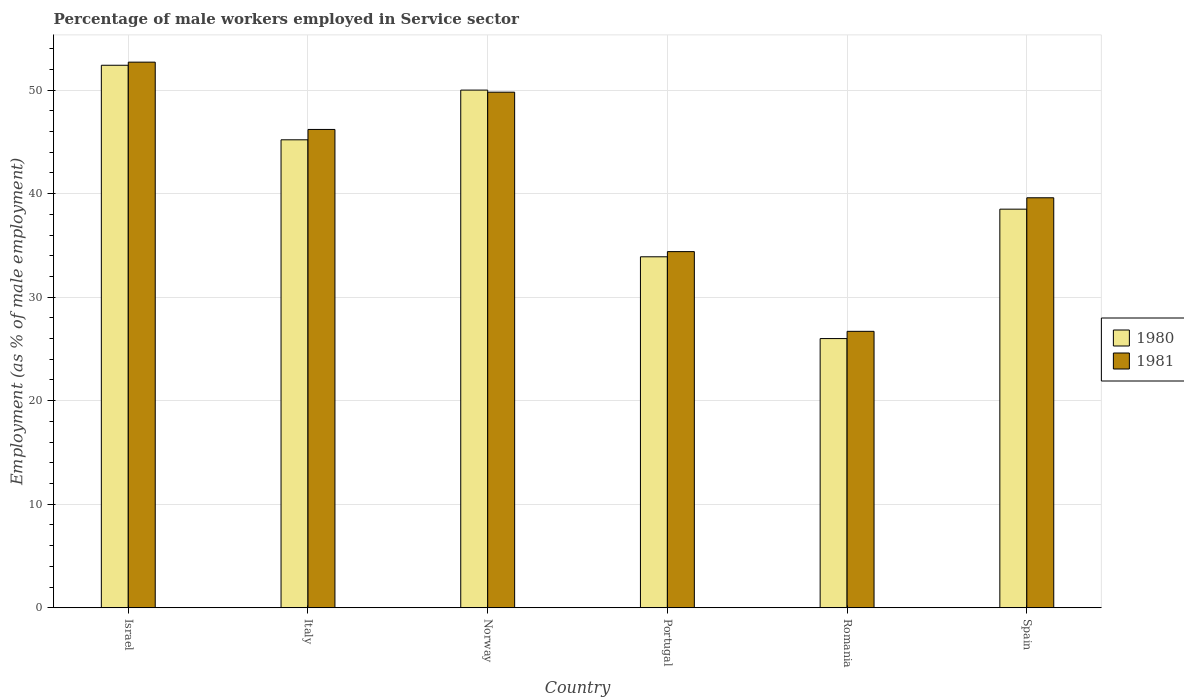How many groups of bars are there?
Provide a succinct answer. 6. Are the number of bars per tick equal to the number of legend labels?
Make the answer very short. Yes. How many bars are there on the 3rd tick from the right?
Provide a succinct answer. 2. In how many cases, is the number of bars for a given country not equal to the number of legend labels?
Your response must be concise. 0. What is the percentage of male workers employed in Service sector in 1981 in Norway?
Give a very brief answer. 49.8. Across all countries, what is the maximum percentage of male workers employed in Service sector in 1980?
Offer a very short reply. 52.4. Across all countries, what is the minimum percentage of male workers employed in Service sector in 1980?
Provide a succinct answer. 26. In which country was the percentage of male workers employed in Service sector in 1981 maximum?
Provide a succinct answer. Israel. In which country was the percentage of male workers employed in Service sector in 1980 minimum?
Ensure brevity in your answer.  Romania. What is the total percentage of male workers employed in Service sector in 1980 in the graph?
Give a very brief answer. 246. What is the difference between the percentage of male workers employed in Service sector in 1980 in Italy and that in Portugal?
Your answer should be very brief. 11.3. What is the difference between the percentage of male workers employed in Service sector in 1981 in Israel and the percentage of male workers employed in Service sector in 1980 in Spain?
Your response must be concise. 14.2. What is the average percentage of male workers employed in Service sector in 1980 per country?
Make the answer very short. 41. What is the difference between the percentage of male workers employed in Service sector of/in 1981 and percentage of male workers employed in Service sector of/in 1980 in Romania?
Provide a succinct answer. 0.7. What is the ratio of the percentage of male workers employed in Service sector in 1981 in Portugal to that in Romania?
Your answer should be compact. 1.29. Is the difference between the percentage of male workers employed in Service sector in 1981 in Italy and Portugal greater than the difference between the percentage of male workers employed in Service sector in 1980 in Italy and Portugal?
Offer a very short reply. Yes. What is the difference between the highest and the second highest percentage of male workers employed in Service sector in 1980?
Offer a terse response. -2.4. What is the difference between the highest and the lowest percentage of male workers employed in Service sector in 1980?
Ensure brevity in your answer.  26.4. What does the 1st bar from the left in Spain represents?
Your response must be concise. 1980. What does the 1st bar from the right in Spain represents?
Ensure brevity in your answer.  1981. How many bars are there?
Your answer should be compact. 12. Are all the bars in the graph horizontal?
Offer a very short reply. No. What is the title of the graph?
Provide a succinct answer. Percentage of male workers employed in Service sector. What is the label or title of the X-axis?
Provide a succinct answer. Country. What is the label or title of the Y-axis?
Make the answer very short. Employment (as % of male employment). What is the Employment (as % of male employment) in 1980 in Israel?
Give a very brief answer. 52.4. What is the Employment (as % of male employment) in 1981 in Israel?
Ensure brevity in your answer.  52.7. What is the Employment (as % of male employment) in 1980 in Italy?
Offer a terse response. 45.2. What is the Employment (as % of male employment) in 1981 in Italy?
Your answer should be very brief. 46.2. What is the Employment (as % of male employment) in 1981 in Norway?
Your answer should be very brief. 49.8. What is the Employment (as % of male employment) of 1980 in Portugal?
Provide a succinct answer. 33.9. What is the Employment (as % of male employment) of 1981 in Portugal?
Keep it short and to the point. 34.4. What is the Employment (as % of male employment) in 1981 in Romania?
Offer a terse response. 26.7. What is the Employment (as % of male employment) in 1980 in Spain?
Give a very brief answer. 38.5. What is the Employment (as % of male employment) in 1981 in Spain?
Make the answer very short. 39.6. Across all countries, what is the maximum Employment (as % of male employment) in 1980?
Provide a succinct answer. 52.4. Across all countries, what is the maximum Employment (as % of male employment) in 1981?
Your answer should be compact. 52.7. Across all countries, what is the minimum Employment (as % of male employment) of 1980?
Give a very brief answer. 26. Across all countries, what is the minimum Employment (as % of male employment) in 1981?
Your answer should be compact. 26.7. What is the total Employment (as % of male employment) of 1980 in the graph?
Make the answer very short. 246. What is the total Employment (as % of male employment) of 1981 in the graph?
Your answer should be very brief. 249.4. What is the difference between the Employment (as % of male employment) of 1981 in Israel and that in Norway?
Provide a succinct answer. 2.9. What is the difference between the Employment (as % of male employment) of 1981 in Israel and that in Portugal?
Offer a terse response. 18.3. What is the difference between the Employment (as % of male employment) of 1980 in Israel and that in Romania?
Keep it short and to the point. 26.4. What is the difference between the Employment (as % of male employment) of 1981 in Israel and that in Romania?
Give a very brief answer. 26. What is the difference between the Employment (as % of male employment) of 1980 in Italy and that in Norway?
Ensure brevity in your answer.  -4.8. What is the difference between the Employment (as % of male employment) in 1981 in Italy and that in Norway?
Provide a succinct answer. -3.6. What is the difference between the Employment (as % of male employment) of 1981 in Italy and that in Portugal?
Provide a short and direct response. 11.8. What is the difference between the Employment (as % of male employment) of 1980 in Italy and that in Romania?
Offer a terse response. 19.2. What is the difference between the Employment (as % of male employment) of 1981 in Italy and that in Romania?
Offer a terse response. 19.5. What is the difference between the Employment (as % of male employment) of 1980 in Italy and that in Spain?
Provide a short and direct response. 6.7. What is the difference between the Employment (as % of male employment) of 1981 in Norway and that in Romania?
Keep it short and to the point. 23.1. What is the difference between the Employment (as % of male employment) in 1981 in Norway and that in Spain?
Keep it short and to the point. 10.2. What is the difference between the Employment (as % of male employment) in 1981 in Portugal and that in Romania?
Offer a very short reply. 7.7. What is the difference between the Employment (as % of male employment) in 1980 in Portugal and that in Spain?
Your response must be concise. -4.6. What is the difference between the Employment (as % of male employment) of 1981 in Portugal and that in Spain?
Make the answer very short. -5.2. What is the difference between the Employment (as % of male employment) in 1980 in Israel and the Employment (as % of male employment) in 1981 in Italy?
Provide a short and direct response. 6.2. What is the difference between the Employment (as % of male employment) in 1980 in Israel and the Employment (as % of male employment) in 1981 in Norway?
Make the answer very short. 2.6. What is the difference between the Employment (as % of male employment) of 1980 in Israel and the Employment (as % of male employment) of 1981 in Portugal?
Ensure brevity in your answer.  18. What is the difference between the Employment (as % of male employment) of 1980 in Israel and the Employment (as % of male employment) of 1981 in Romania?
Your answer should be compact. 25.7. What is the difference between the Employment (as % of male employment) in 1980 in Israel and the Employment (as % of male employment) in 1981 in Spain?
Keep it short and to the point. 12.8. What is the difference between the Employment (as % of male employment) of 1980 in Italy and the Employment (as % of male employment) of 1981 in Portugal?
Provide a succinct answer. 10.8. What is the difference between the Employment (as % of male employment) in 1980 in Norway and the Employment (as % of male employment) in 1981 in Portugal?
Give a very brief answer. 15.6. What is the difference between the Employment (as % of male employment) in 1980 in Norway and the Employment (as % of male employment) in 1981 in Romania?
Your response must be concise. 23.3. What is the difference between the Employment (as % of male employment) in 1980 in Portugal and the Employment (as % of male employment) in 1981 in Spain?
Provide a succinct answer. -5.7. What is the difference between the Employment (as % of male employment) in 1980 in Romania and the Employment (as % of male employment) in 1981 in Spain?
Make the answer very short. -13.6. What is the average Employment (as % of male employment) of 1981 per country?
Provide a short and direct response. 41.57. What is the difference between the Employment (as % of male employment) of 1980 and Employment (as % of male employment) of 1981 in Israel?
Offer a very short reply. -0.3. What is the difference between the Employment (as % of male employment) in 1980 and Employment (as % of male employment) in 1981 in Romania?
Your answer should be compact. -0.7. What is the ratio of the Employment (as % of male employment) in 1980 in Israel to that in Italy?
Make the answer very short. 1.16. What is the ratio of the Employment (as % of male employment) in 1981 in Israel to that in Italy?
Provide a short and direct response. 1.14. What is the ratio of the Employment (as % of male employment) of 1980 in Israel to that in Norway?
Offer a very short reply. 1.05. What is the ratio of the Employment (as % of male employment) of 1981 in Israel to that in Norway?
Keep it short and to the point. 1.06. What is the ratio of the Employment (as % of male employment) in 1980 in Israel to that in Portugal?
Your answer should be very brief. 1.55. What is the ratio of the Employment (as % of male employment) in 1981 in Israel to that in Portugal?
Your answer should be very brief. 1.53. What is the ratio of the Employment (as % of male employment) in 1980 in Israel to that in Romania?
Your response must be concise. 2.02. What is the ratio of the Employment (as % of male employment) of 1981 in Israel to that in Romania?
Ensure brevity in your answer.  1.97. What is the ratio of the Employment (as % of male employment) in 1980 in Israel to that in Spain?
Offer a very short reply. 1.36. What is the ratio of the Employment (as % of male employment) of 1981 in Israel to that in Spain?
Your answer should be compact. 1.33. What is the ratio of the Employment (as % of male employment) of 1980 in Italy to that in Norway?
Your answer should be compact. 0.9. What is the ratio of the Employment (as % of male employment) in 1981 in Italy to that in Norway?
Keep it short and to the point. 0.93. What is the ratio of the Employment (as % of male employment) of 1981 in Italy to that in Portugal?
Offer a terse response. 1.34. What is the ratio of the Employment (as % of male employment) in 1980 in Italy to that in Romania?
Provide a succinct answer. 1.74. What is the ratio of the Employment (as % of male employment) of 1981 in Italy to that in Romania?
Provide a succinct answer. 1.73. What is the ratio of the Employment (as % of male employment) of 1980 in Italy to that in Spain?
Your answer should be compact. 1.17. What is the ratio of the Employment (as % of male employment) of 1980 in Norway to that in Portugal?
Ensure brevity in your answer.  1.47. What is the ratio of the Employment (as % of male employment) of 1981 in Norway to that in Portugal?
Your answer should be compact. 1.45. What is the ratio of the Employment (as % of male employment) of 1980 in Norway to that in Romania?
Offer a terse response. 1.92. What is the ratio of the Employment (as % of male employment) of 1981 in Norway to that in Romania?
Offer a terse response. 1.87. What is the ratio of the Employment (as % of male employment) of 1980 in Norway to that in Spain?
Your response must be concise. 1.3. What is the ratio of the Employment (as % of male employment) of 1981 in Norway to that in Spain?
Give a very brief answer. 1.26. What is the ratio of the Employment (as % of male employment) in 1980 in Portugal to that in Romania?
Offer a very short reply. 1.3. What is the ratio of the Employment (as % of male employment) of 1981 in Portugal to that in Romania?
Offer a terse response. 1.29. What is the ratio of the Employment (as % of male employment) of 1980 in Portugal to that in Spain?
Your answer should be compact. 0.88. What is the ratio of the Employment (as % of male employment) in 1981 in Portugal to that in Spain?
Provide a short and direct response. 0.87. What is the ratio of the Employment (as % of male employment) in 1980 in Romania to that in Spain?
Ensure brevity in your answer.  0.68. What is the ratio of the Employment (as % of male employment) in 1981 in Romania to that in Spain?
Keep it short and to the point. 0.67. What is the difference between the highest and the second highest Employment (as % of male employment) of 1980?
Provide a succinct answer. 2.4. What is the difference between the highest and the lowest Employment (as % of male employment) in 1980?
Your answer should be compact. 26.4. 